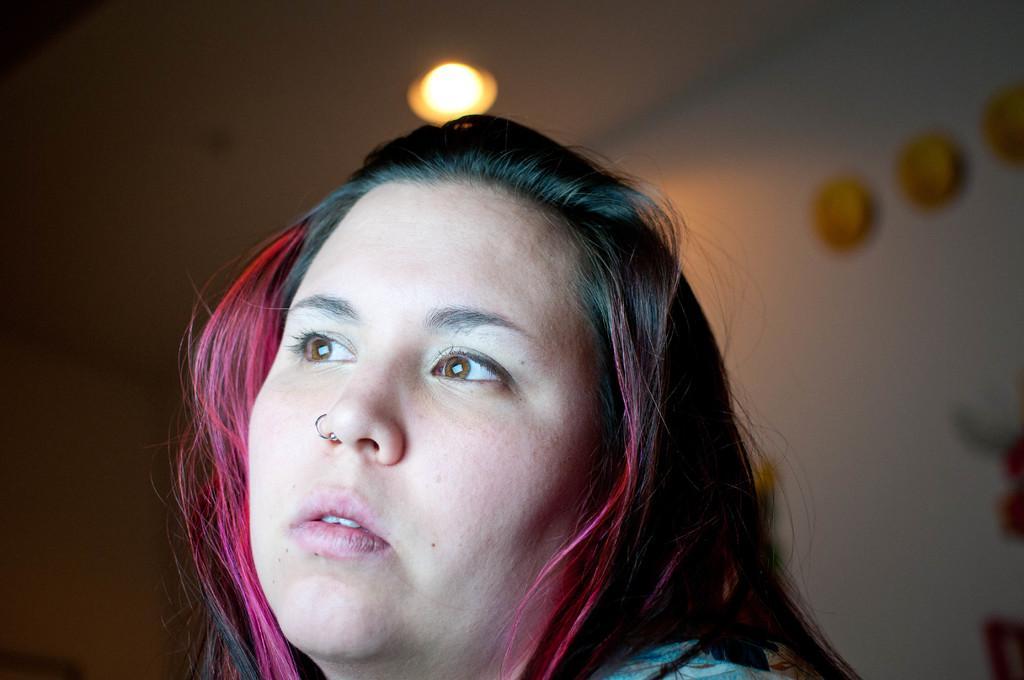Describe this image in one or two sentences. In this image in the foreground there is one woman and there is a blurry background, and we could see lights and some objects and wall. 